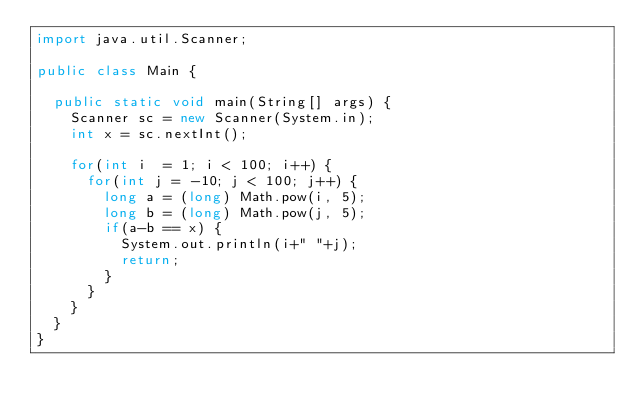<code> <loc_0><loc_0><loc_500><loc_500><_Java_>import java.util.Scanner;
 
public class Main {
 
	public static void main(String[] args) {
		Scanner sc = new Scanner(System.in);
		int x = sc.nextInt();
		
		for(int i  = 1; i < 100; i++) {
			for(int j = -10; j < 100; j++) {
				long a = (long) Math.pow(i, 5);
				long b = (long) Math.pow(j, 5);
				if(a-b == x) {
					System.out.println(i+" "+j);
					return;
				}
			}
		}
	}
}</code> 